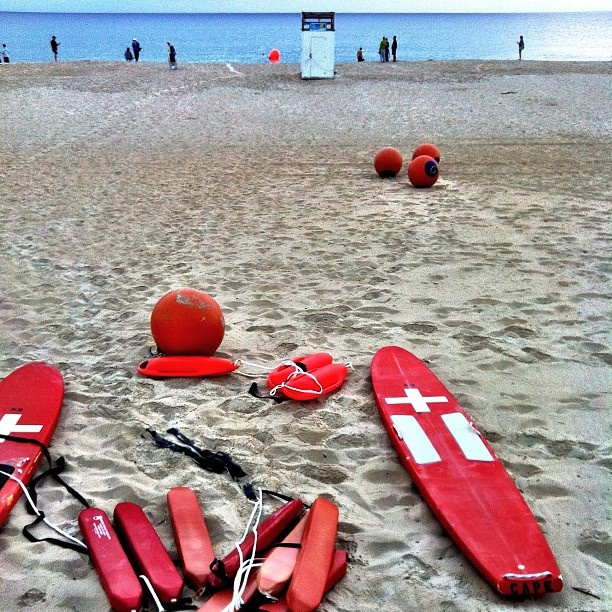Describe the objects in this image and their specific colors. I can see surfboard in lightblue, brown, white, and salmon tones, surfboard in lightblue, brown, and white tones, sports ball in lightblue, brown, maroon, and salmon tones, sports ball in lightblue, maroon, black, and brown tones, and sports ball in lightblue, maroon, brown, and black tones in this image. 